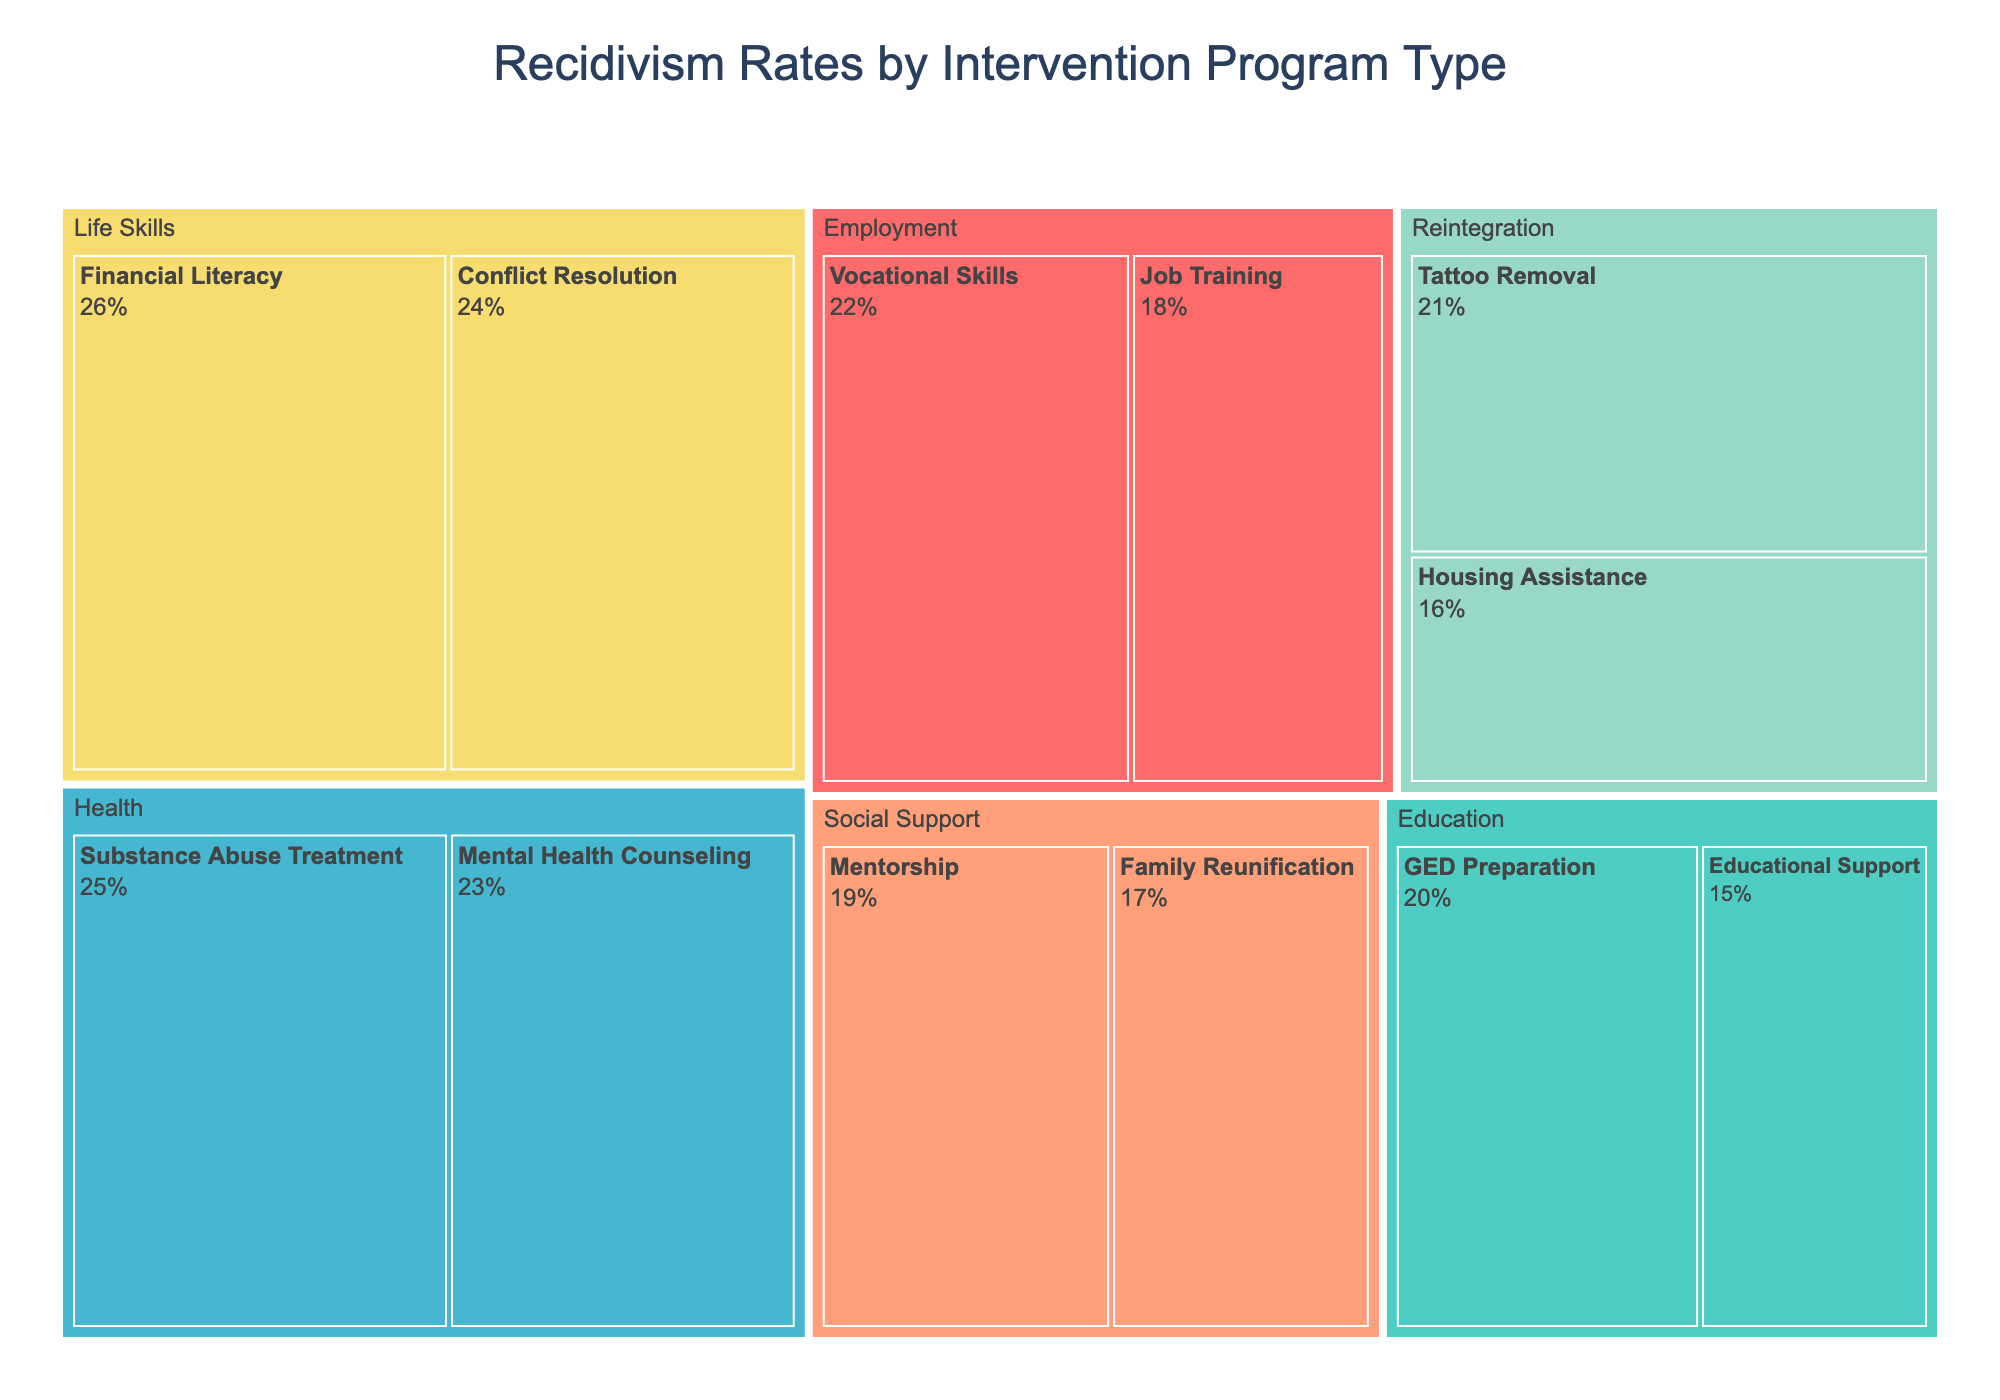What is the title of the figure? The title of the figure is displayed at the top and it reads "Recidivism Rates by Intervention Program Type".
Answer: "Recidivism Rates by Intervention Program Type" Which category has the lowest recidivism rate? To find the category with the lowest recidivism rate, look at the rates associated with each category. The lowest rate is in the "Education" category at 15% for Educational Support.
Answer: Education What is the recidivism rate for Substance Abuse Treatment? Find Substance Abuse Treatment under the category "Health" in the treemap and note the rate shown within the block. The recidivism rate is 25%.
Answer: 25% What are the two intervention programs under the "Life Skills" category? Look for the "Life Skills" category in the treemap and identify the two blocks under it. They are "Conflict Resolution" and "Financial Literacy".
Answer: Conflict Resolution and Financial Literacy Which program in the "Social Support" category has a recidivism rate higher than 17%? Under the "Social Support" category, compare the recidivism rates. "Mentorship" has a recidivism rate higher than 17%, specifically at 19%.
Answer: Mentorship What is the average recidivism rate of the programs in the "Employment" category? The programs in the Employment category are "Job Training" and "Vocational Skills" with rates of 18% and 22% respectively. The average is calculated as (18 + 22) / 2 = 20.
Answer: 20 How many intervention programs have a recidivism rate greater than 20%? Count the programs with rates above 20%. They are: "Vocational Skills" (22%), "Substance Abuse Treatment" (25%), "Mental Health Counseling" (23%), "Tattoo Removal" (21%), and "Conflict Resolution" (24%), and "Financial Literacy" (26%). There are 6 programs in total.
Answer: 6 Which category has the most programs listed? Compare the number of blocks in each category. "Employment," "Health," and "Social Support" categories have the same number of programs listed, which is 2 each, but the maximum is 3 in the "Life Skills" category.
Answer: Life Skills Among "Job Training" and "GED Preparation," which has a lower recidivism rate? Compare the recidivism rates for "Job Training" (18%) and "GED Preparation" (20%). "Job Training" has a lower rate.
Answer: Job Training What is the sum of recidivism rates for all programs in the "Health" category? Add the recidivism rates under the "Health" category: 25% (Substance Abuse Treatment) + 23% (Mental Health Counseling) = 48%.
Answer: 48 